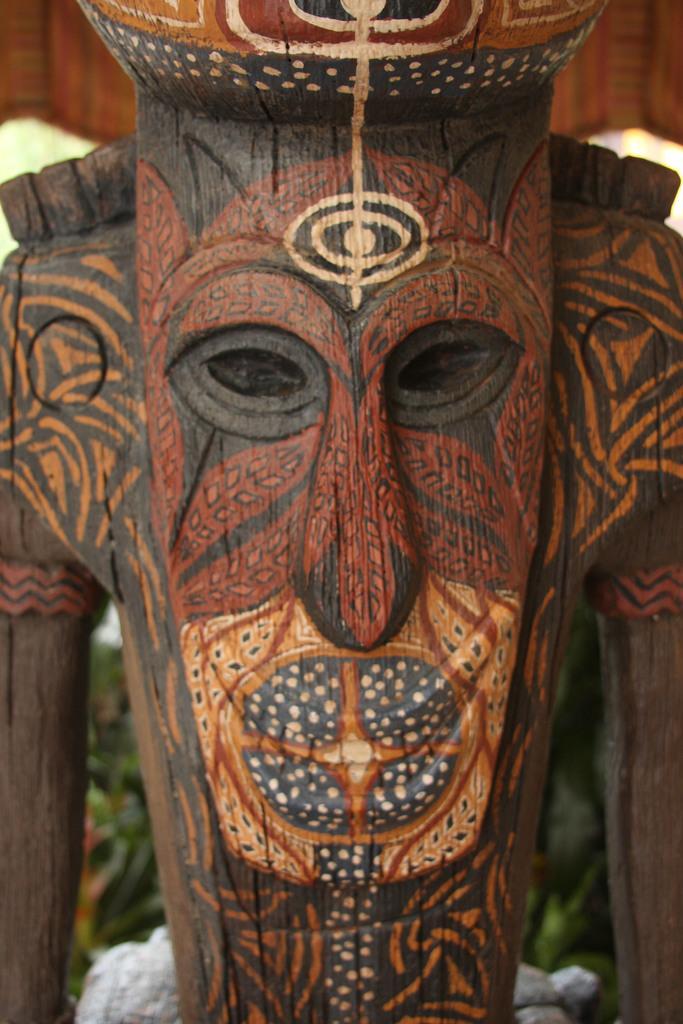Could you give a brief overview of what you see in this image? Here we can see wooden craft mask. Background it is blur. 